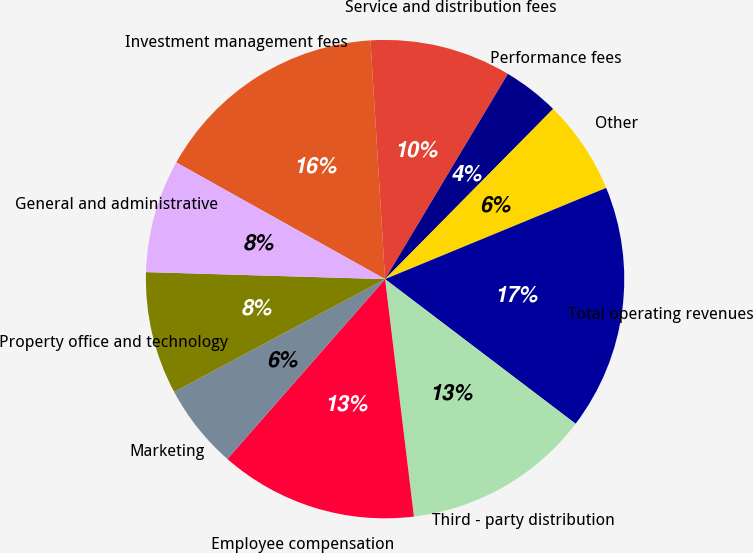Convert chart. <chart><loc_0><loc_0><loc_500><loc_500><pie_chart><fcel>Investment management fees<fcel>Service and distribution fees<fcel>Performance fees<fcel>Other<fcel>Total operating revenues<fcel>Third - party distribution<fcel>Employee compensation<fcel>Marketing<fcel>Property office and technology<fcel>General and administrative<nl><fcel>15.92%<fcel>9.55%<fcel>3.82%<fcel>6.37%<fcel>16.56%<fcel>12.74%<fcel>13.38%<fcel>5.73%<fcel>8.28%<fcel>7.64%<nl></chart> 